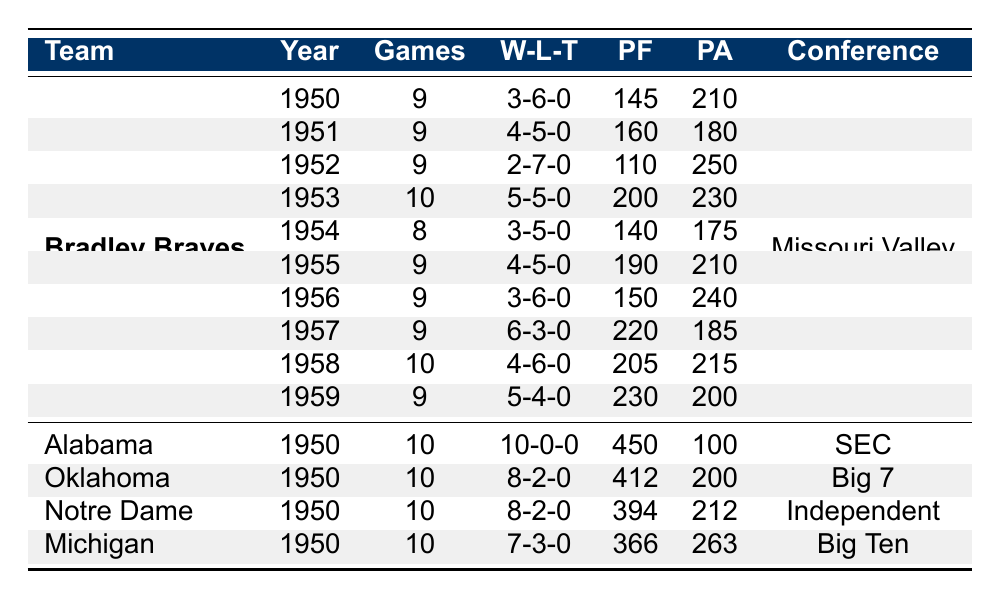What was the win-loss record of the Bradley Braves in 1954? In 1954, the Bradley Braves had 3 wins, 5 losses, and 0 ties, which is expressed as a win-loss record of 3-5-0.
Answer: 3-5-0 How many points did the University of Alabama score in 1950? The table indicates that the University of Alabama scored a total of 450 points in 1950.
Answer: 450 Which team played the most games in 1950? The University of Alabama played 10 games in 1950, which is the highest number compared to other teams listed for that year.
Answer: University of Alabama What is the total number of wins for the Bradley Braves from 1950 to 1959? To find the total wins, we sum the wins across all years: 3 + 4 + 2 + 5 + 3 + 4 + 3 + 6 + 4 + 5 = 43.
Answer: 43 Did the Bradley Braves have a winning season in 1957? In 1957, the Bradley Braves won 6 games and lost 3 games (6-3-0), indicating a winning season as wins exceed losses.
Answer: Yes What is the difference in points scored by Bradley Braves and University of Alabama in 1950? The Bradley Braves scored 145 points, while the University of Alabama scored 450. Thus, the difference is 450 - 145 = 305.
Answer: 305 What was the win-loss ratio of the Bradley Braves in 1953? The win-loss ratio is calculated as follows: Wins (5) divided by Losses (5) gives a win-loss ratio of 1, as both values are equal.
Answer: 1 Which team had the best point differential in 1950? The point differential is found by subtracting Points Against from Points For. Alabama had 450 - 100 = 350, Oklahoma had 412 - 200 = 212, Notre Dame had 394 - 212 = 182, and Michigan had 366 - 263 = 103. Therefore, Alabama had the best differential of 350.
Answer: Alabama How many ties did the Bradley Braves have during the 1950s? The table shows that the Bradley Braves had 0 ties in each of their seasons between 1950 and 1959, hence the total number of ties is 0.
Answer: 0 Which team had the highest overall wins in the year 1950? The win counts for 1950 show Alabama with 10 wins, which is higher than any other team's count for that year.
Answer: University of Alabama 